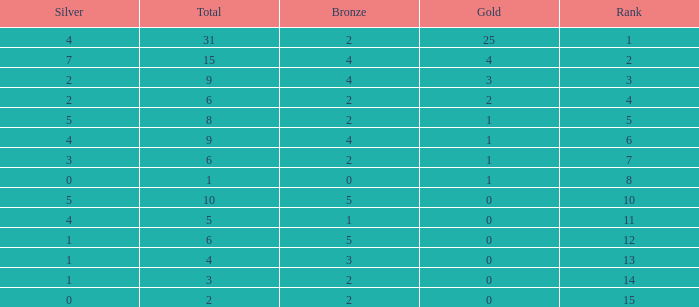What is the highest rank of the medal total less than 15, more than 2 bronzes, 0 gold and 1 silver? 13.0. 